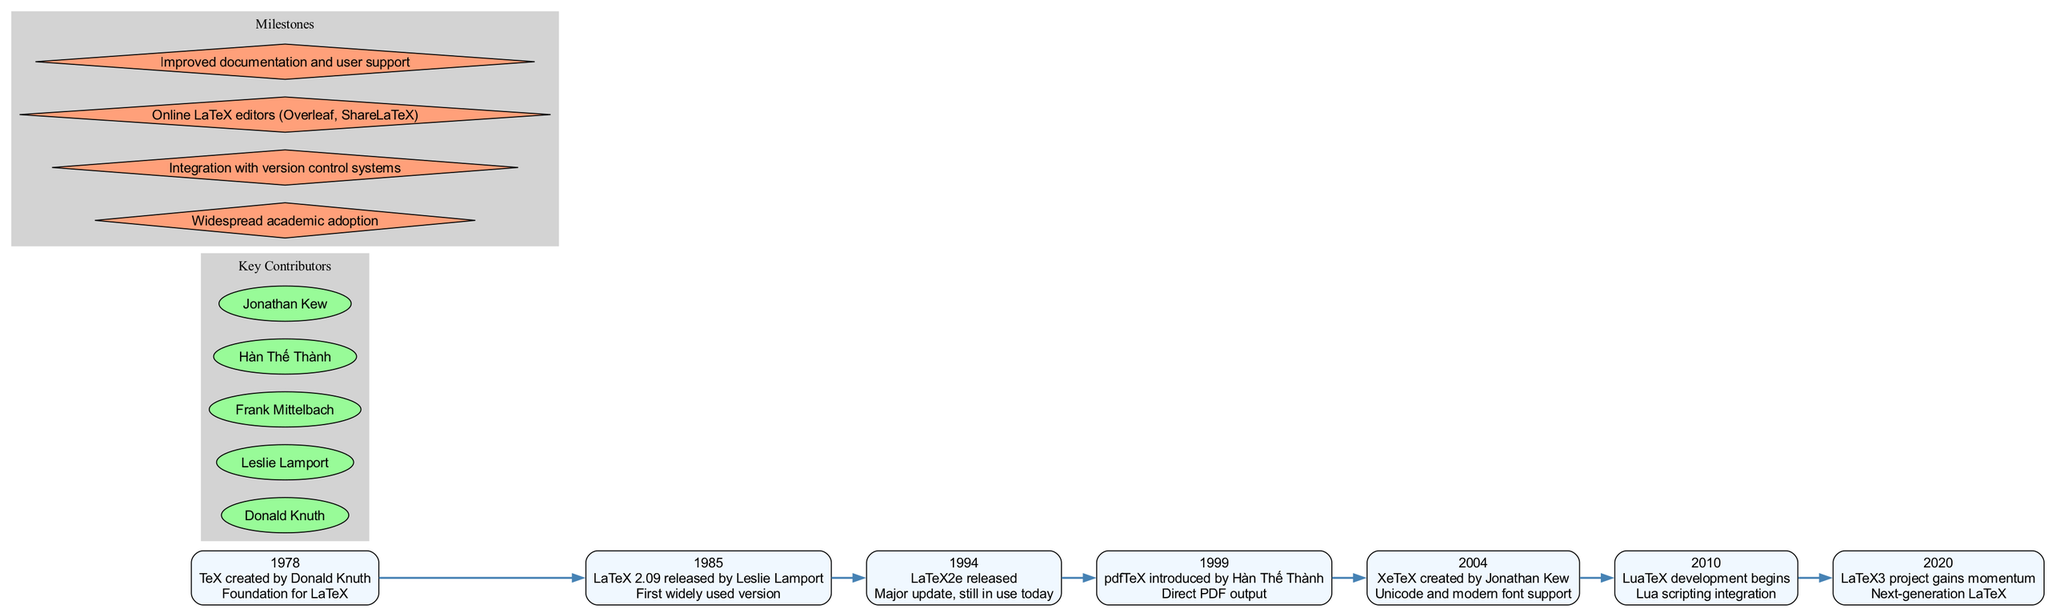What year was LaTeX 2.09 released? The timeline node for LaTeX 2.09 indicates the year 1985.
Answer: 1985 Who created pdfTeX? The timeline shows that pdfTeX was introduced by Hàn Thế Thành.
Answer: Hàn Thế Thành How many key contributors are mentioned? The key contributors section lists five individuals.
Answer: 5 Which event corresponds to the year 2020? In 2020, the LaTeX3 project gains momentum as noted on the timeline.
Answer: LaTeX3 project gains momentum What relationship exists between TeX and LaTeX? The diagram connects TeX (created in 1978) as the foundation for LaTeX, indicating that LaTeX was developed based on TeX.
Answer: Foundation for LaTeX What is a significant milestone in LaTeX development? Among the milestones, "Widespread academic adoption" is noted prominently.
Answer: Widespread academic adoption Which version was the first widely used? The timeline states that LaTeX 2.09 was the first widely used version.
Answer: LaTeX 2.09 Which development introduced modern font support? The timeline specifies that XeTeX, created by Jonathan Kew in 2004, introduced modern font support.
Answer: XeTeX What is the last entry of the timeline? The final entry in the timeline is for the LaTeX3 project gaining momentum in the year 2020.
Answer: LaTeX3 project gains momentum 